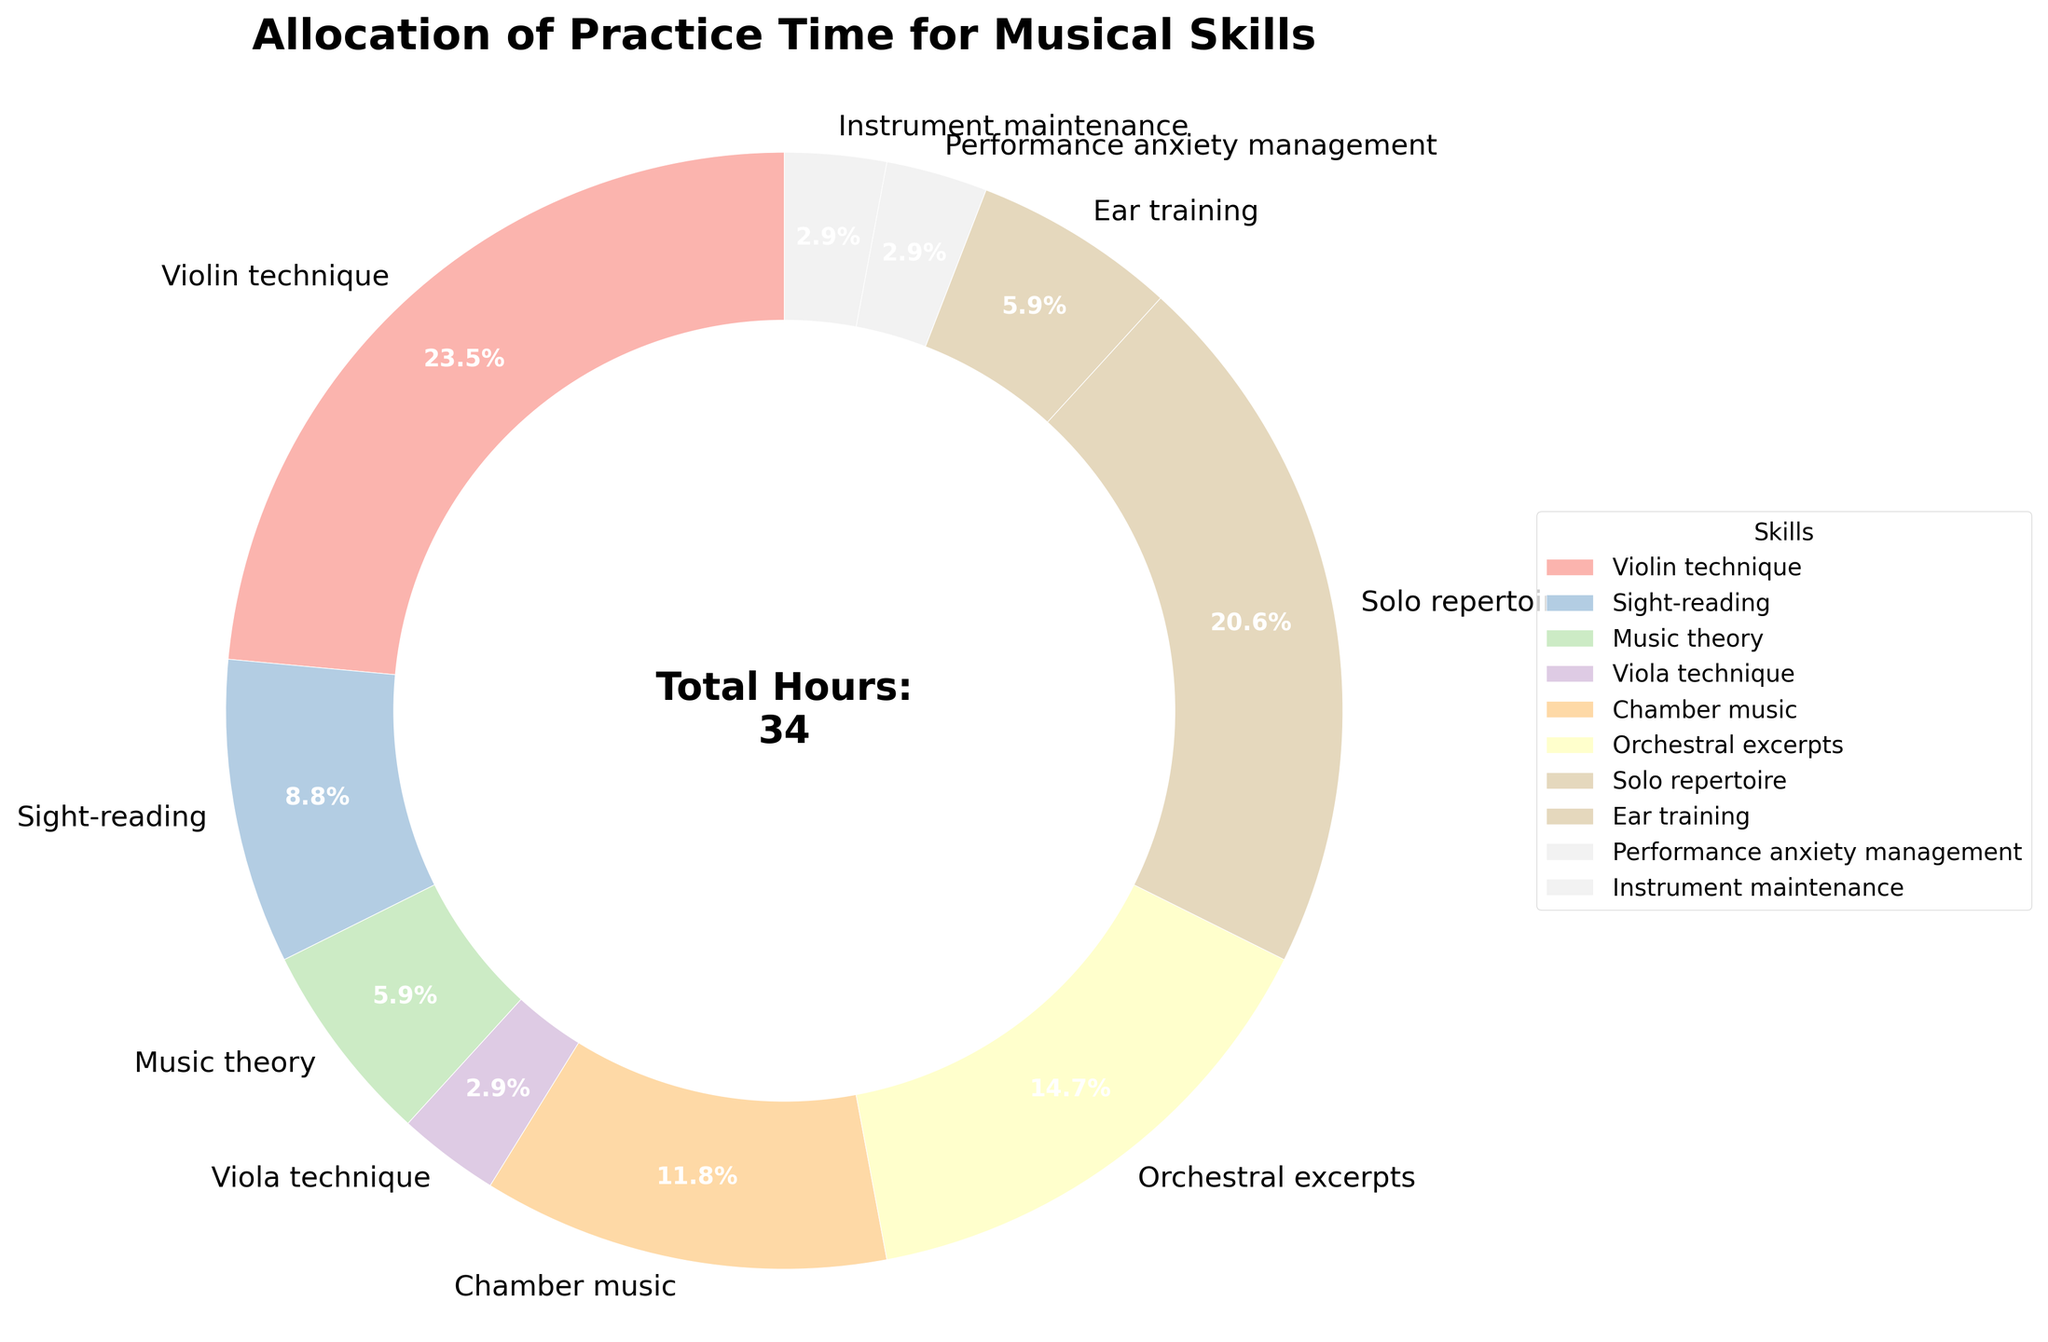What's the total number of practice hours for violin technique and solo repertoire combined? To find the total number of practice hours for violin technique and solo repertoire, add the hours for both skills: Violin technique (8 hours) + Solo repertoire (7 hours) = 15 hours
Answer: 15 hours Which skill has the least allocated practice time? By examining the pie chart, we can see that three skills have the smallest segments, each with 1-hour allocations: Viola technique, Performance anxiety management, and Instrument maintenance. Hence, any of these skills could be considered as having the least allocated time.
Answer: Viola technique/Performance anxiety management/Instrument maintenance What percentage of the total practice time is allocated to orchestral excerpts? The figure shows that orchestral excerpts account for 5 hours. To find the percentage, divide by the total practice hours (34) and multiply by 100. (5/34) * 100 = approximately 14.7%
Answer: 14.7% How does the practice time for sight-reading compare to that for ear training? Sight-reading practice time is shown as 3 hours, and ear training is 2 hours. Therefore, sight-reading has 1 more hour of practice time than ear training.
Answer: 1 hour more What's the combined percentage of practice time for chamber music and music theory? Chamber music accounts for 4 hours and music theory for 2 hours. Combined, that is 4 + 2 = 6 hours. To find the percentage: (6/34) * 100 = approximately 17.6%
Answer: 17.6% Which skill's practice segment is visually the largest, and why? The segment for violin technique appears to be the largest visually. It represents 8 hours out of the total 34 hours, which is the highest allocation for any single skill.
Answer: Violin technique If you average the practice hours dedicated to sight-reading, music theory, and ear training, what do you get? Adding the hours for sight-reading (3 hours), music theory (2 hours), and ear training (2 hours) gives us 7 hours. The average is 7/3 = approximately 2.33 hours
Answer: 2.33 hours Which skill takes up exactly the same amount of practice time as performance anxiety management? Reviewing the pie chart, instrument maintenance also takes up 1 hour, which is the same as performance anxiety management.
Answer: Instrument maintenance What's the difference in practice time between solo repertoire and chamber music? Solo repertoire is allocated 7 hours, while chamber music is allocated 4 hours. The difference is 7 - 4 = 3 hours
Answer: 3 hours 